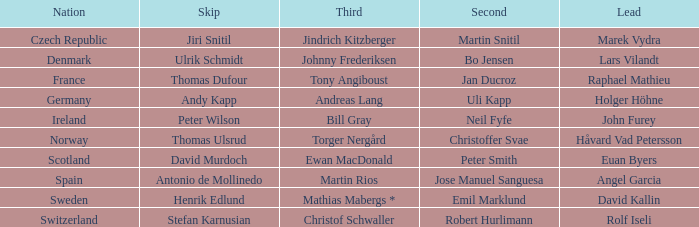Which Lead has a Nation of switzerland? Rolf Iseli. 